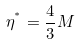Convert formula to latex. <formula><loc_0><loc_0><loc_500><loc_500>\eta ^ { ^ { * } } = \frac { 4 } { 3 } M</formula> 